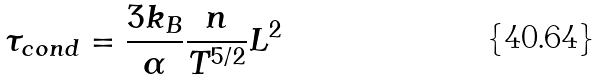Convert formula to latex. <formula><loc_0><loc_0><loc_500><loc_500>\tau _ { c o n d } = \frac { 3 k _ { B } } { \alpha } \frac { n } { T ^ { 5 / 2 } } L ^ { 2 }</formula> 